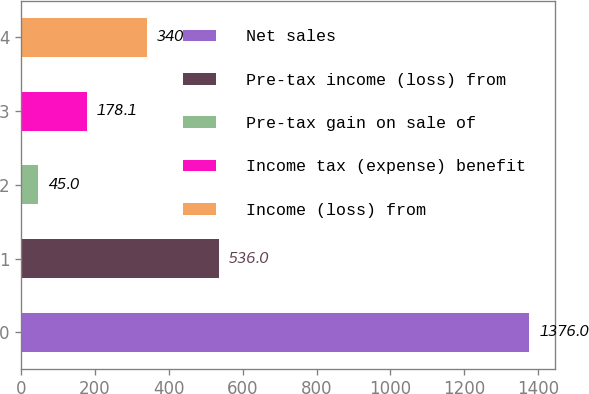<chart> <loc_0><loc_0><loc_500><loc_500><bar_chart><fcel>Net sales<fcel>Pre-tax income (loss) from<fcel>Pre-tax gain on sale of<fcel>Income tax (expense) benefit<fcel>Income (loss) from<nl><fcel>1376<fcel>536<fcel>45<fcel>178.1<fcel>340<nl></chart> 